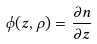<formula> <loc_0><loc_0><loc_500><loc_500>\phi ( z , \rho ) = \frac { \partial n } { \partial z }</formula> 